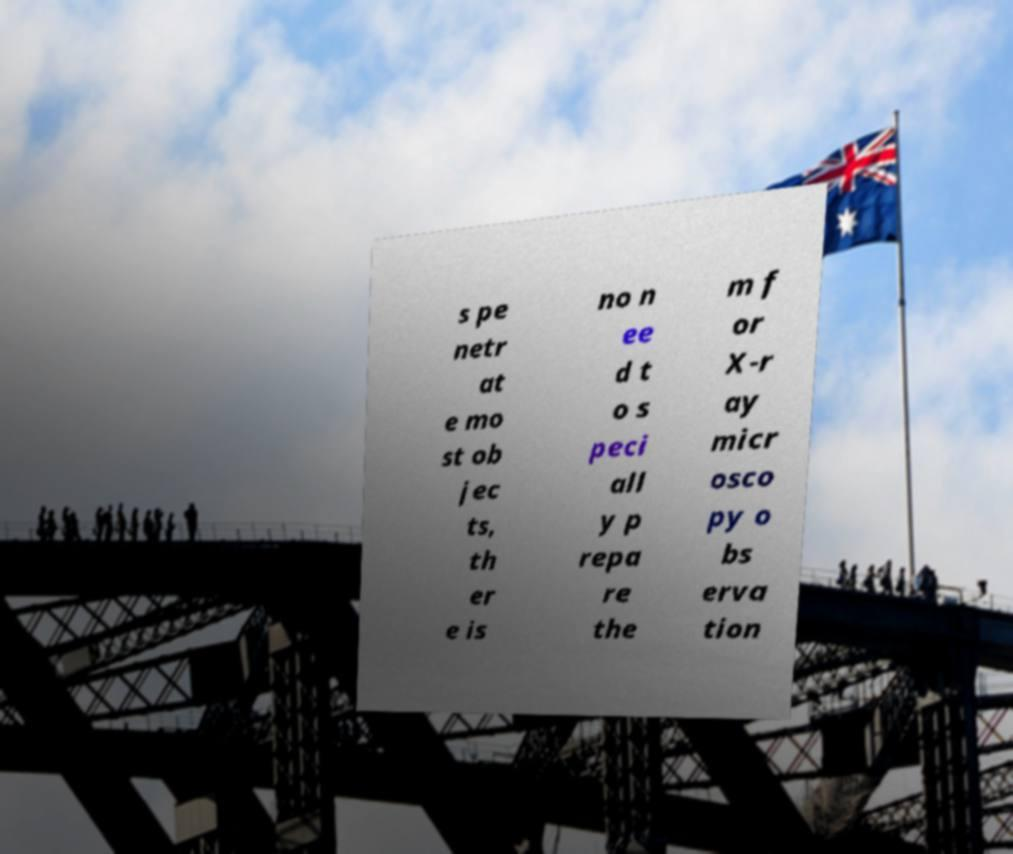Please identify and transcribe the text found in this image. s pe netr at e mo st ob jec ts, th er e is no n ee d t o s peci all y p repa re the m f or X-r ay micr osco py o bs erva tion 